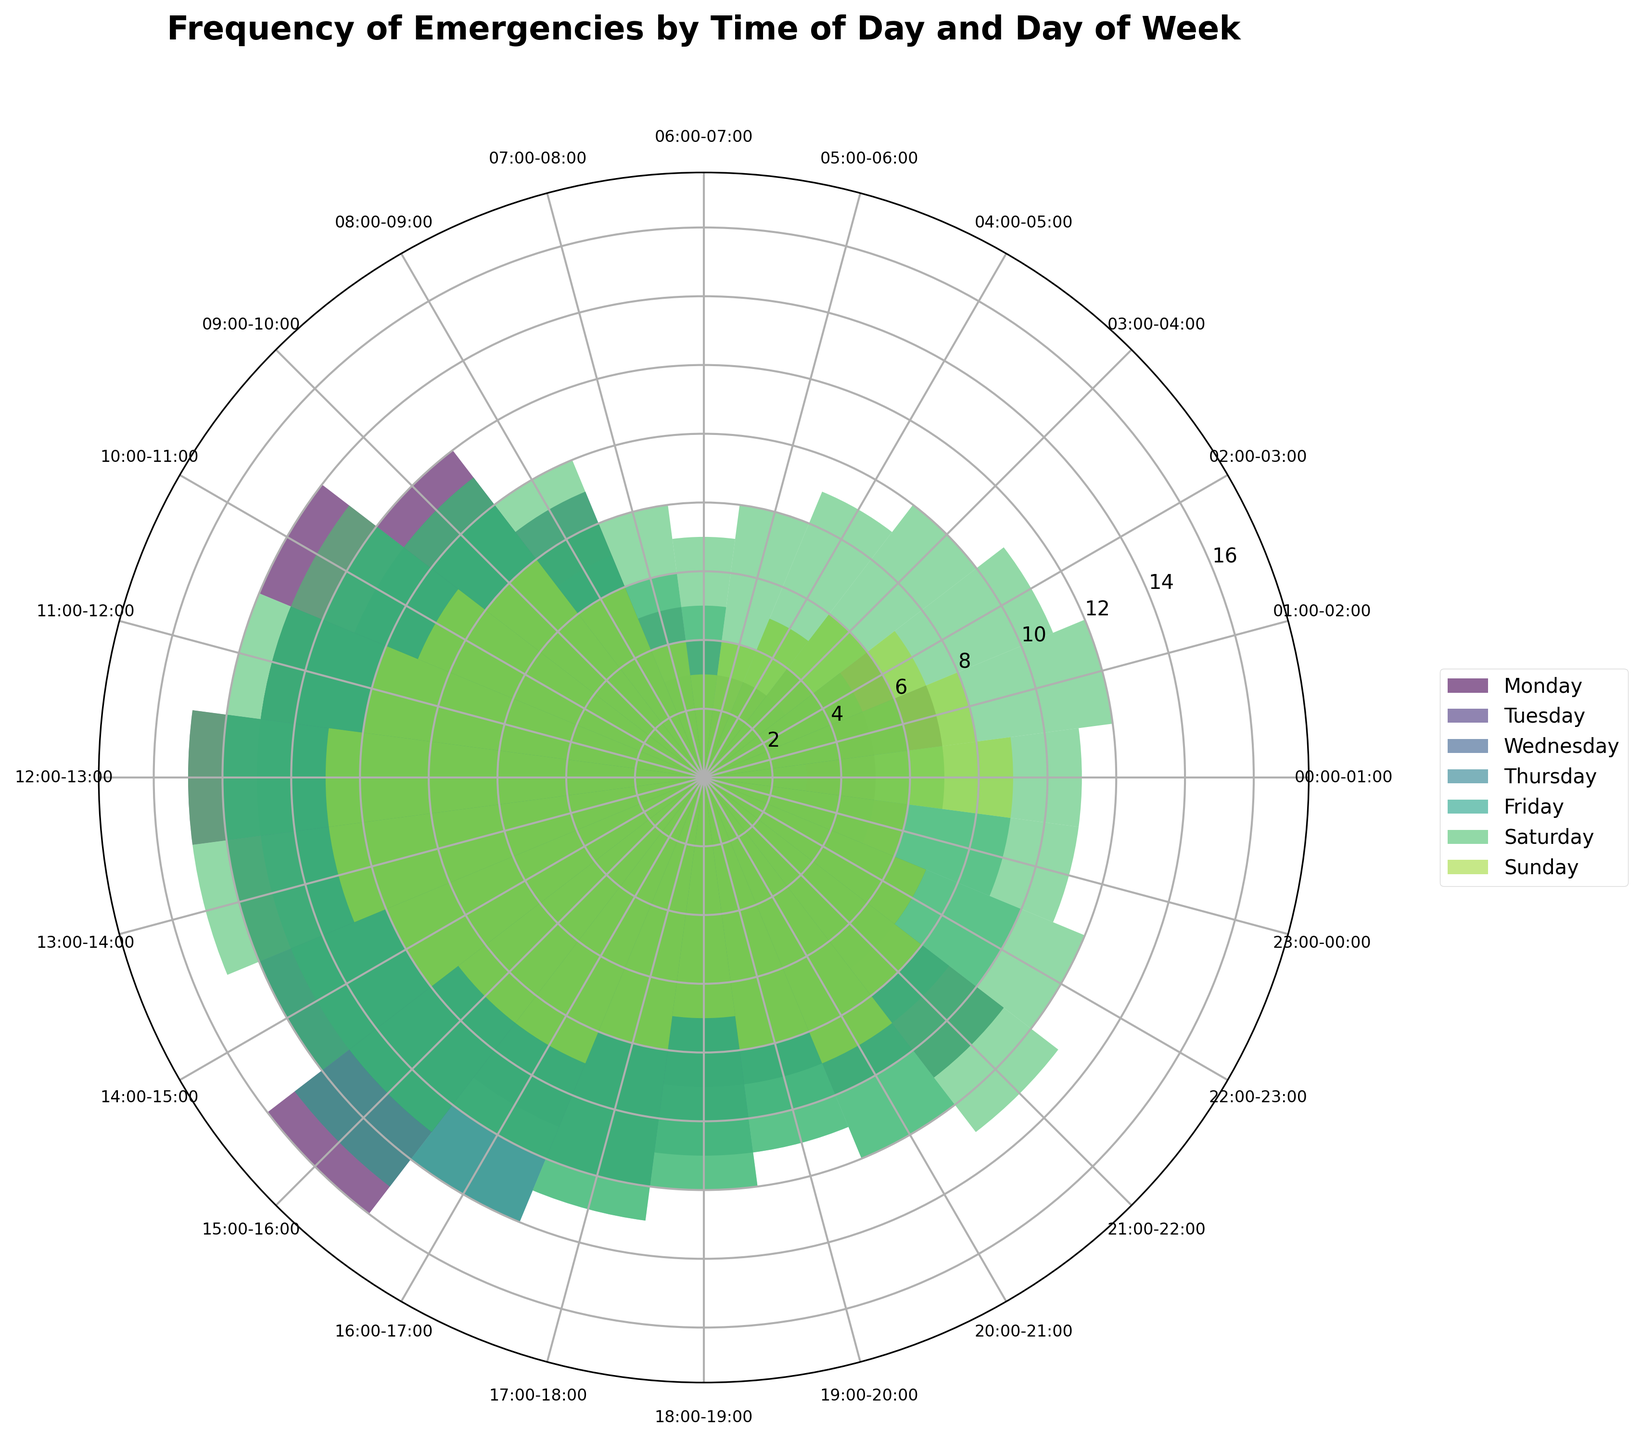What is the title of the chart? The chart title is usually displayed at the top of the chart. In this case, the bold font text at the top reads "Frequency of Emergencies by Time of Day and Day of Week"
Answer: Frequency of Emergencies by Time of Day and Day of Week How many days of the week are represented in the chart? There are labels for each day in the legend section of the chart, indicating the number of days. The labels show Monday, Tuesday, Wednesday, Thursday, Friday, Saturday, and Sunday, making it a total of 7 days
Answer: 7 Which day has the highest frequency of emergencies around midday (12:00-13:00)? To find this, look at the lengths of the bars for each day, specifically for the time segment labeled 12:00-13:00. The longest bar for this segment belongs to Saturday.
Answer: Saturday During which hour is the peak frequency of emergencies for Monday? Check the heights of the bars for each hour on Monday. The time segment with the tallest bar indicates the peak frequency. For Monday, the segment 15:00-16:00 has the tallest bar.
Answer: 15:00-16:00 On which day is the frequency of emergencies between 01:00-02:00 the highest? Look for the time segment labeled 01:00-02:00 and compare the lengths of the bars for each day. Saturday has the tallest bar for this segment.
Answer: Saturday What is the average frequency of emergencies for Tuesday between 14:00-17:00? First identify the frequencies for Tuesday within this time range: 14:00-15:00 (14), 15:00-16:00 (13), and 16:00-17:00 (12). Then find the average: (14 + 13 + 12)/3 = 39/3 = 13
Answer: 13 Which day generally has the highest frequency of emergencies in the late evening (20:00-00:00)? Focus on the late evening time segments (20:00-21:00 to 23:00-00:00) for each day. Calculate the sum of frequencies for these segments for each day. Saturday has the highest total frequency compared to the other days.
Answer: Saturday During which hour do Sundays have their highest frequency of emergencies? For every hour on Sunday, look at the heights of the bars and determine which one is the tallest. On Sunday, the highest frequency occurs around 20:00-21:00.
Answer: 20:00-21:00 What is the range (difference between the maximum and minimum) of emergency frequencies on Thursday? Find the highest and lowest frequencies on Thursday by checking each bar's height. The highest is at 15:00-16:00 with 14, and the lowest is at 05:00-06:00 with 2. The range is 14 - 2 = 12.
Answer: 12 